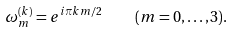Convert formula to latex. <formula><loc_0><loc_0><loc_500><loc_500>\omega _ { m } ^ { ( k ) } = e ^ { i \pi k m / 2 } \quad ( m = 0 , \dots , 3 ) .</formula> 